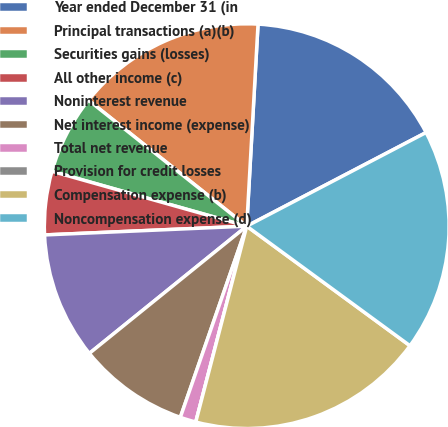Convert chart to OTSL. <chart><loc_0><loc_0><loc_500><loc_500><pie_chart><fcel>Year ended December 31 (in<fcel>Principal transactions (a)(b)<fcel>Securities gains (losses)<fcel>All other income (c)<fcel>Noninterest revenue<fcel>Net interest income (expense)<fcel>Total net revenue<fcel>Provision for credit losses<fcel>Compensation expense (b)<fcel>Noncompensation expense (d)<nl><fcel>16.45%<fcel>15.19%<fcel>6.33%<fcel>5.06%<fcel>10.13%<fcel>8.86%<fcel>1.27%<fcel>0.0%<fcel>18.99%<fcel>17.72%<nl></chart> 